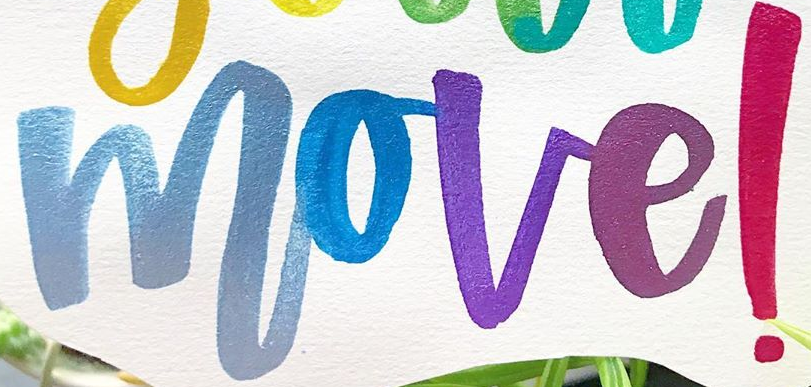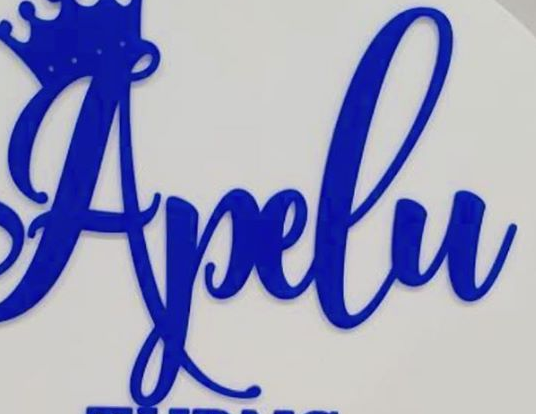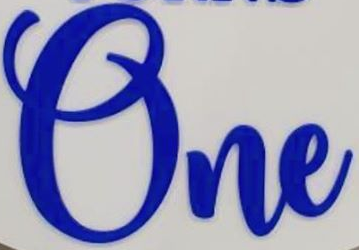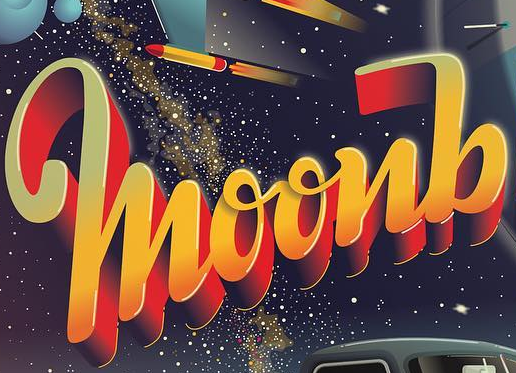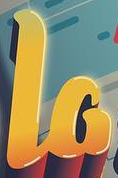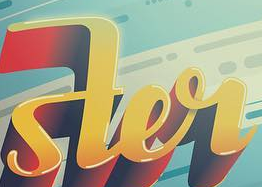What text is displayed in these images sequentially, separated by a semicolon? move!; Apelu; One; moonb; la; ster 